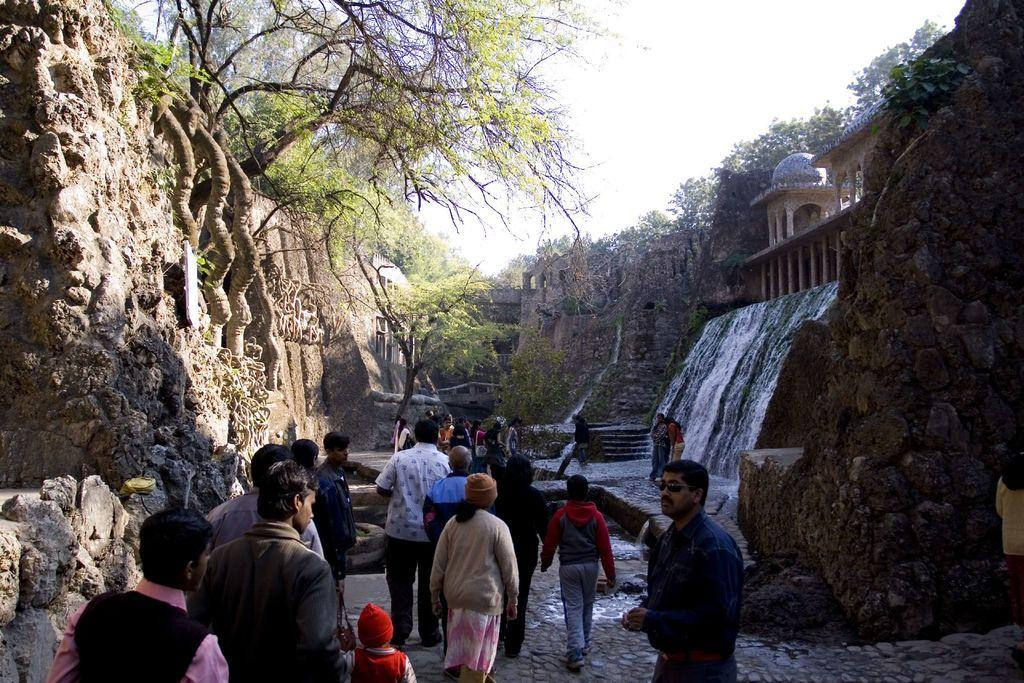What can be seen in the image involving multiple individuals? There are groups of people standing in the image. What type of natural elements are present in the image? There are trees and hills in the image. What type of geographical feature can be seen in the image? There is a waterfall in the image. What type of man-made structures are present in the image? There is ancient architecture in the image. What is visible in the background of the image? The sky is visible in the background of the image. What type of shirt is the hill wearing in the image? There is no shirt present in the image, as the hill is a geographical feature and not a person. What type of earth can be seen in the image? The image does not specifically focus on the type of earth, but it does show a natural landscape with trees, hills, and a waterfall. 